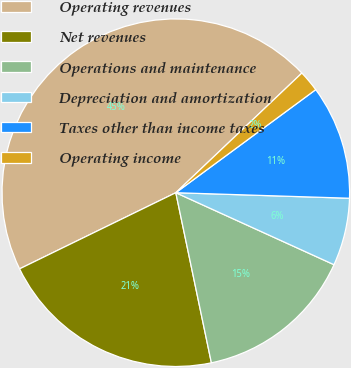<chart> <loc_0><loc_0><loc_500><loc_500><pie_chart><fcel>Operating revenues<fcel>Net revenues<fcel>Operations and maintenance<fcel>Depreciation and amortization<fcel>Taxes other than income taxes<fcel>Operating income<nl><fcel>45.13%<fcel>21.06%<fcel>14.92%<fcel>6.29%<fcel>10.61%<fcel>1.98%<nl></chart> 